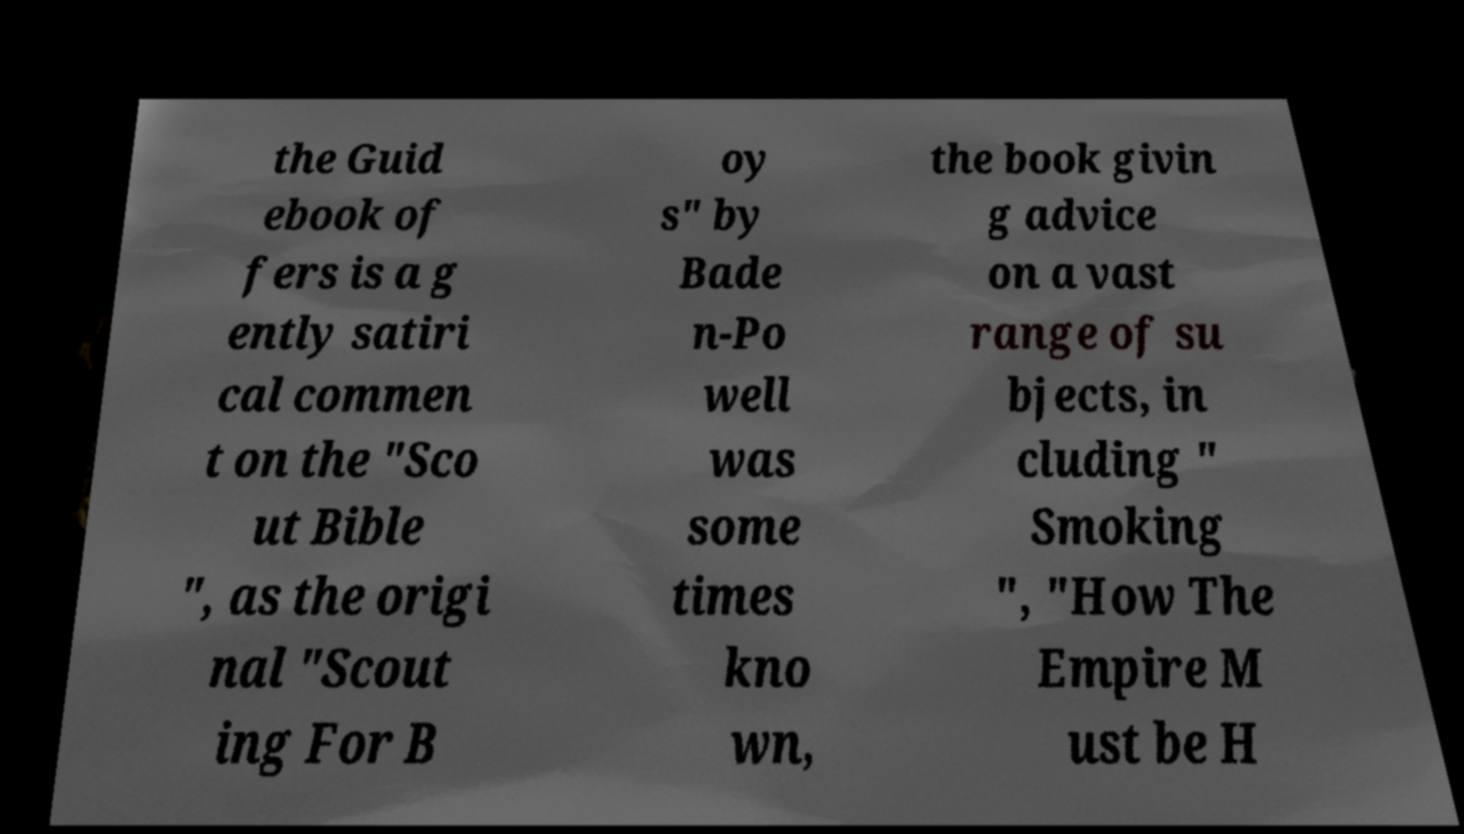Could you assist in decoding the text presented in this image and type it out clearly? the Guid ebook of fers is a g ently satiri cal commen t on the "Sco ut Bible ", as the origi nal "Scout ing For B oy s" by Bade n-Po well was some times kno wn, the book givin g advice on a vast range of su bjects, in cluding " Smoking ", "How The Empire M ust be H 